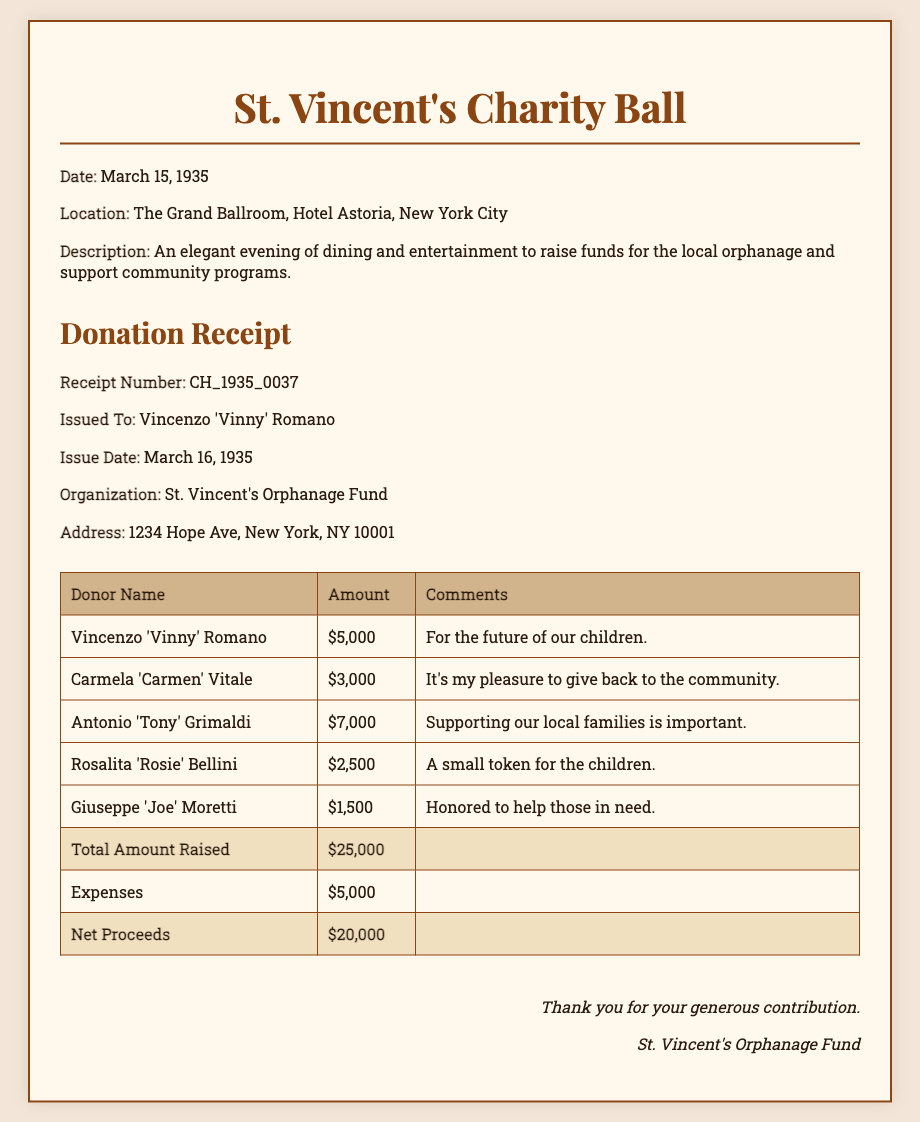What is the date of the charity event? The date of the charity event is specifically mentioned in the document as March 15, 1935.
Answer: March 15, 1935 Who received the receipt? The document states that the receipt was issued to Vincenzo 'Vinny' Romano.
Answer: Vincenzo 'Vinny' Romano How much did Antonio 'Tony' Grimaldi donate? The donation amount from Antonio 'Tony' Grimaldi is listed in the table as $7,000.
Answer: $7,000 What is the total amount raised from donations? The total amount raised is indicated in the table as $25,000.
Answer: $25,000 What was the net proceeds after expenses? The net proceeds are calculated as total raised minus expenses and are mentioned as $20,000 in the document.
Answer: $20,000 Where was the charity event held? The event location is specified as The Grand Ballroom, Hotel Astoria, New York City.
Answer: The Grand Ballroom, Hotel Astoria, New York City What is the purpose of the event? The purpose of the event is clearly described as raising funds for the local orphanage and supporting community programs.
Answer: Raising funds for the local orphanage What is the total amount listed under expenses? The document specifies the expenses amount as $5,000.
Answer: $5,000 What type of document is this? The document is a donation receipt related to a charity event.
Answer: Donation receipt 